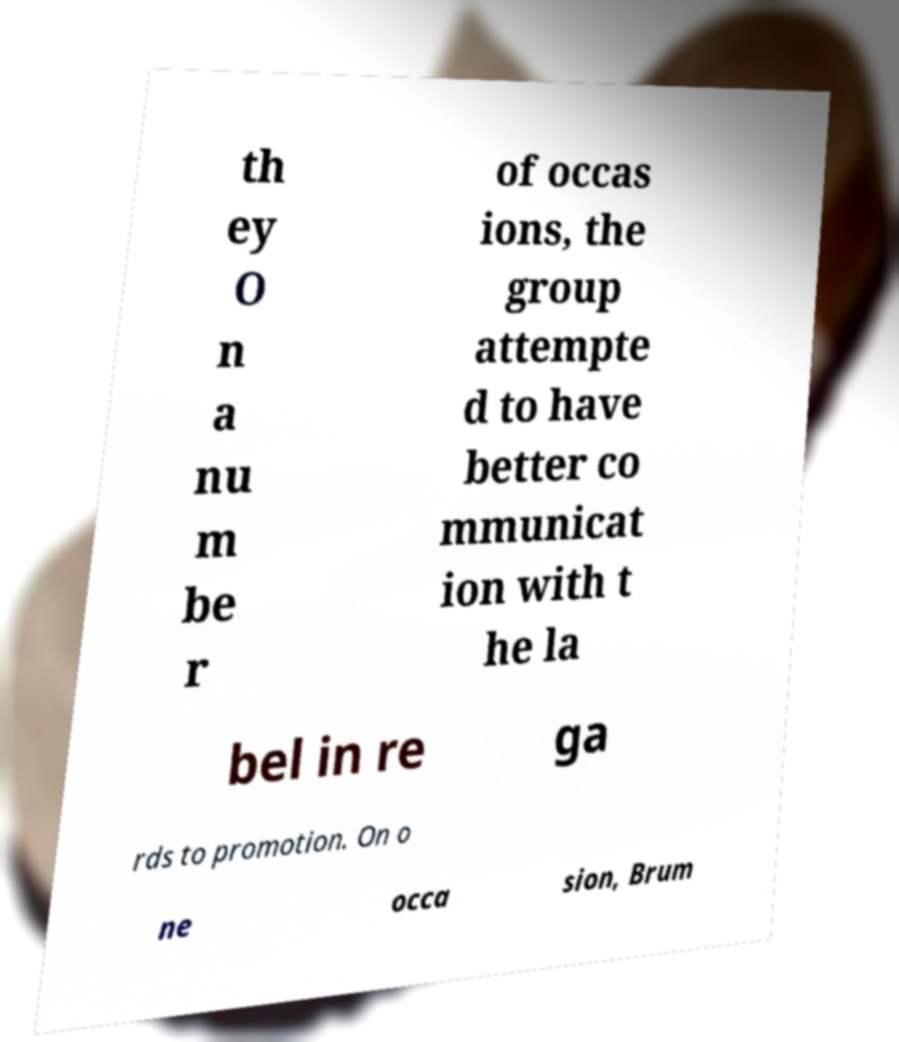What messages or text are displayed in this image? I need them in a readable, typed format. th ey O n a nu m be r of occas ions, the group attempte d to have better co mmunicat ion with t he la bel in re ga rds to promotion. On o ne occa sion, Brum 